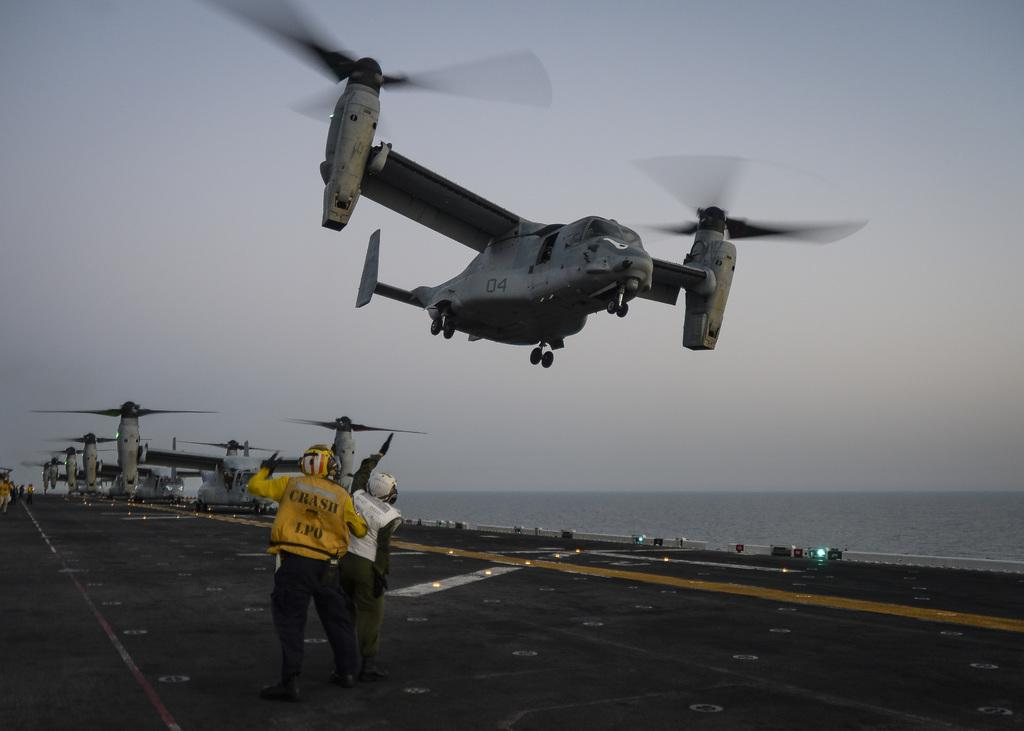Provide a one-sentence caption for the provided image. A man in a yellow crash jacket assisting the planes in take-off. 